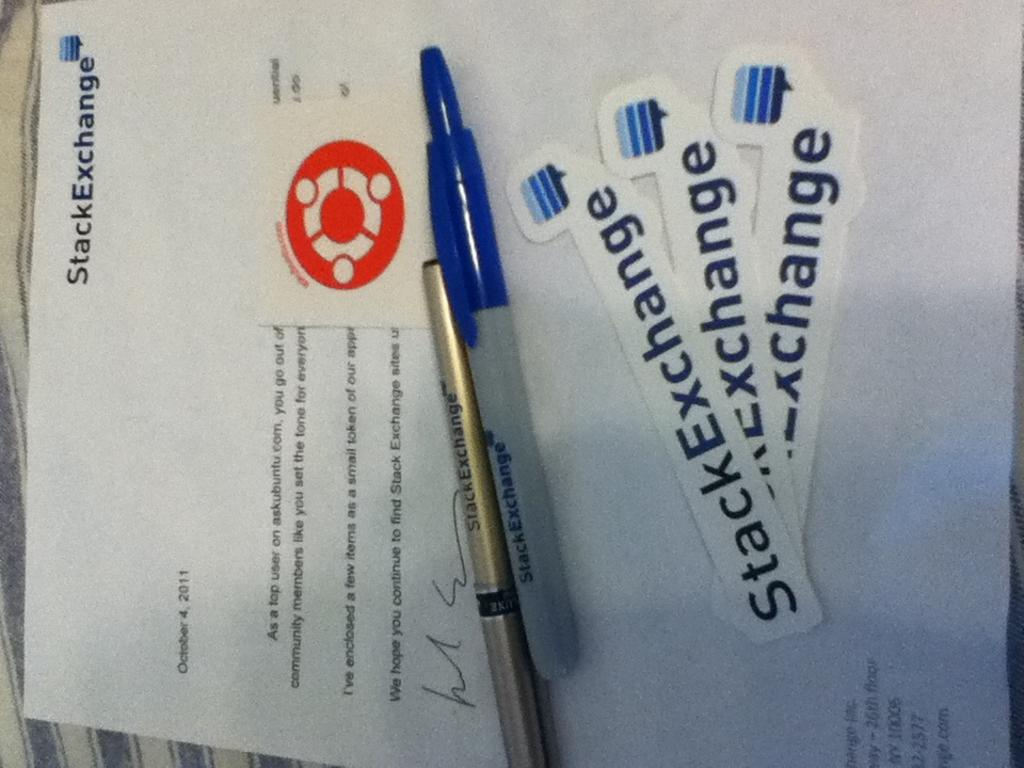What is on the paper that is visible in the image? There is a paper with text and a logo in the image. What objects can be used for writing in the image? There are pens in the image. What type of material is visible in the image? There is a cloth visible in the image. What type of coal is being used to write on the paper in the image? There is no coal present in the image; the pens are used for writing. 